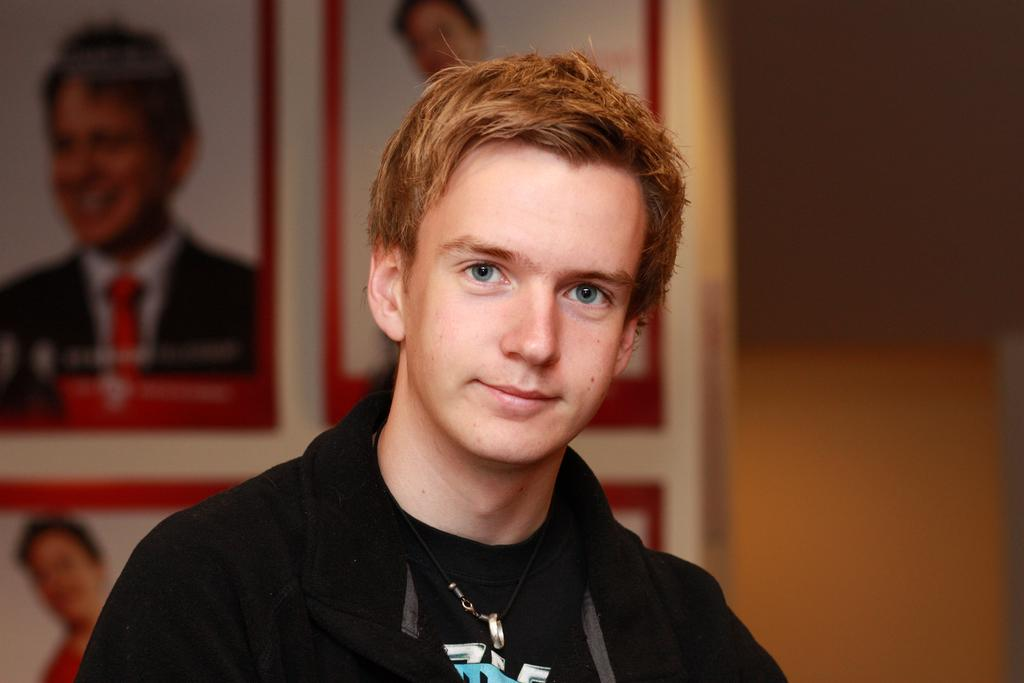What is the main subject in the foreground of the image? There is a person in the foreground of the image. What can be seen in the background of the image? There are photo frames and a wall visible in the background of the image. What type of gold territory is visible in the image? There is no gold territory present in the image. 